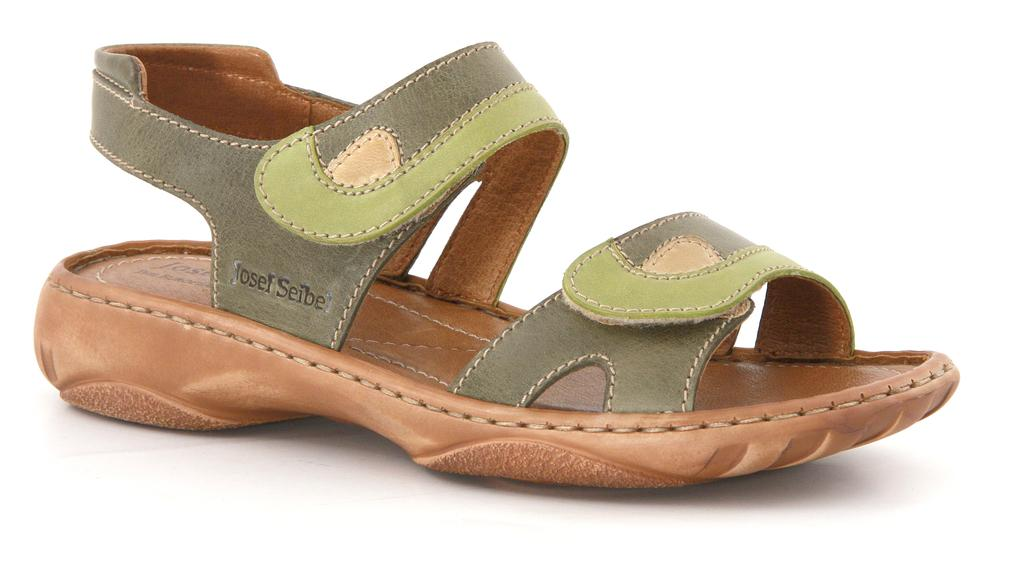What type of object is in the image? There is a footwear in the image. What color is the background of the image? The background of the image is white. What type of competition is taking place in the image? There is no competition present in the image; it only features footwear and a white background. Is there a fire visible in the image? No, there is no fire present in the image. 